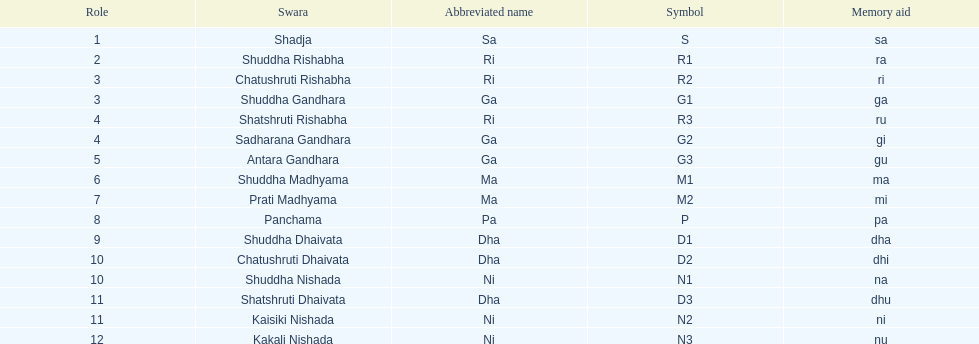Could you parse the entire table? {'header': ['Role', 'Swara', 'Abbreviated name', 'Symbol', 'Memory aid'], 'rows': [['1', 'Shadja', 'Sa', 'S', 'sa'], ['2', 'Shuddha Rishabha', 'Ri', 'R1', 'ra'], ['3', 'Chatushruti Rishabha', 'Ri', 'R2', 'ri'], ['3', 'Shuddha Gandhara', 'Ga', 'G1', 'ga'], ['4', 'Shatshruti Rishabha', 'Ri', 'R3', 'ru'], ['4', 'Sadharana Gandhara', 'Ga', 'G2', 'gi'], ['5', 'Antara Gandhara', 'Ga', 'G3', 'gu'], ['6', 'Shuddha Madhyama', 'Ma', 'M1', 'ma'], ['7', 'Prati Madhyama', 'Ma', 'M2', 'mi'], ['8', 'Panchama', 'Pa', 'P', 'pa'], ['9', 'Shuddha Dhaivata', 'Dha', 'D1', 'dha'], ['10', 'Chatushruti Dhaivata', 'Dha', 'D2', 'dhi'], ['10', 'Shuddha Nishada', 'Ni', 'N1', 'na'], ['11', 'Shatshruti Dhaivata', 'Dha', 'D3', 'dhu'], ['11', 'Kaisiki Nishada', 'Ni', 'N2', 'ni'], ['12', 'Kakali Nishada', 'Ni', 'N3', 'nu']]} What swara comes after shatshruti dhaivata? Shuddha Nishada. 